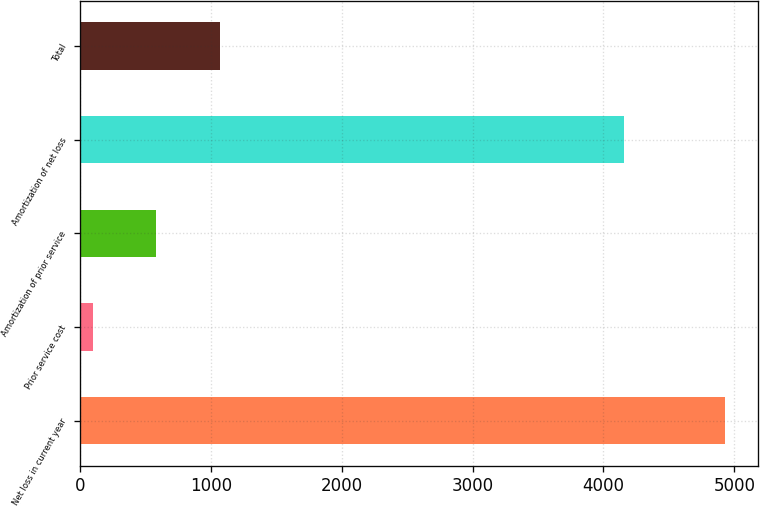<chart> <loc_0><loc_0><loc_500><loc_500><bar_chart><fcel>Net loss in current year<fcel>Prior service cost<fcel>Amortization of prior service<fcel>Amortization of net loss<fcel>Total<nl><fcel>4931<fcel>101<fcel>584<fcel>4161<fcel>1067<nl></chart> 